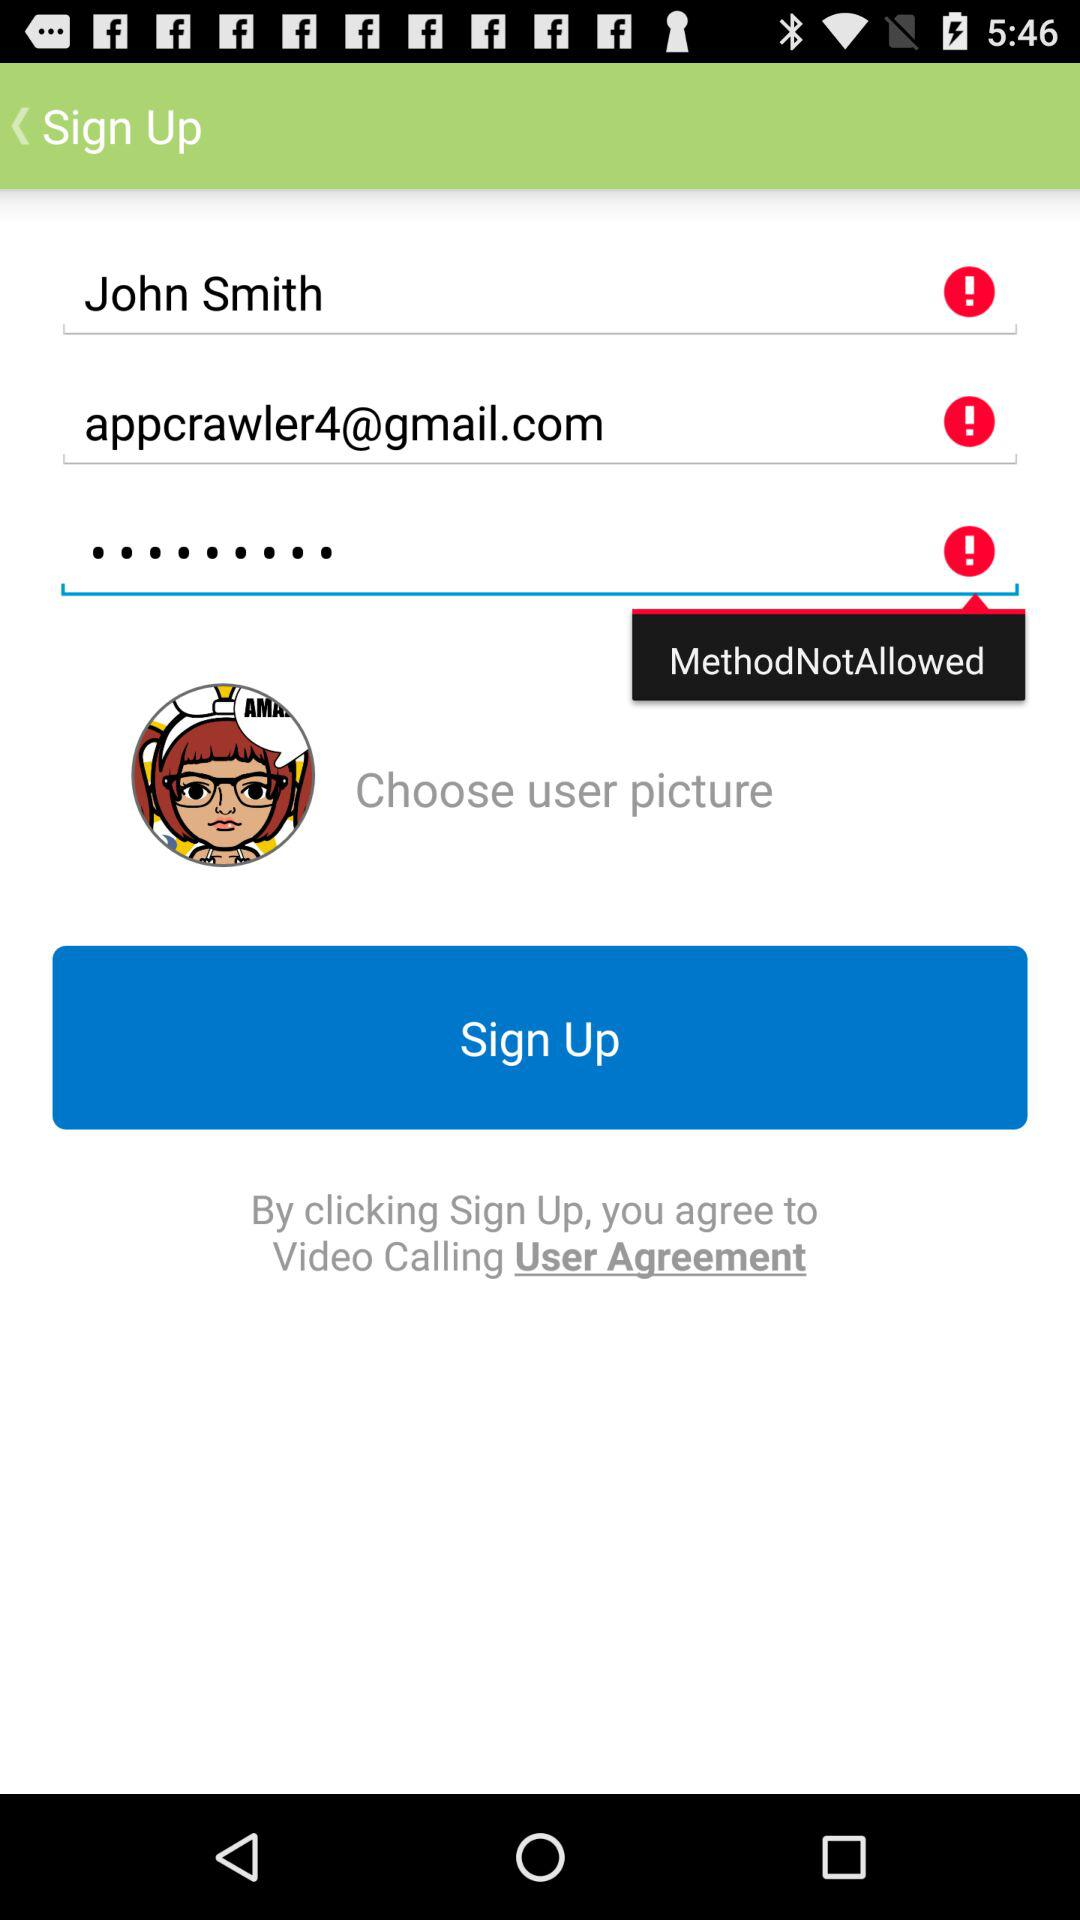What is the email address? The email address is appcrawler4@gmail.com. 